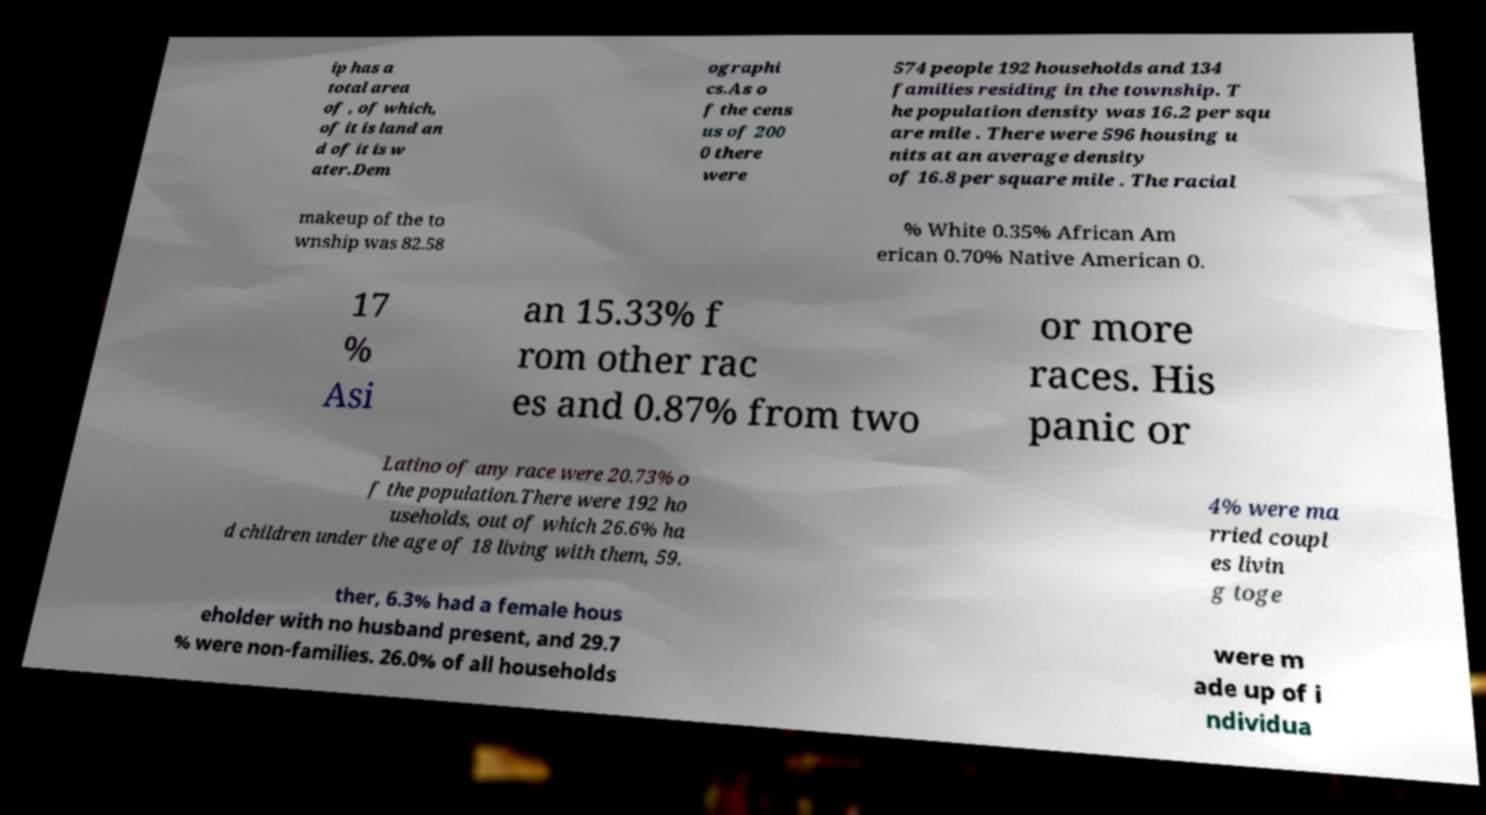For documentation purposes, I need the text within this image transcribed. Could you provide that? ip has a total area of , of which, of it is land an d of it is w ater.Dem ographi cs.As o f the cens us of 200 0 there were 574 people 192 households and 134 families residing in the township. T he population density was 16.2 per squ are mile . There were 596 housing u nits at an average density of 16.8 per square mile . The racial makeup of the to wnship was 82.58 % White 0.35% African Am erican 0.70% Native American 0. 17 % Asi an 15.33% f rom other rac es and 0.87% from two or more races. His panic or Latino of any race were 20.73% o f the population.There were 192 ho useholds, out of which 26.6% ha d children under the age of 18 living with them, 59. 4% were ma rried coupl es livin g toge ther, 6.3% had a female hous eholder with no husband present, and 29.7 % were non-families. 26.0% of all households were m ade up of i ndividua 